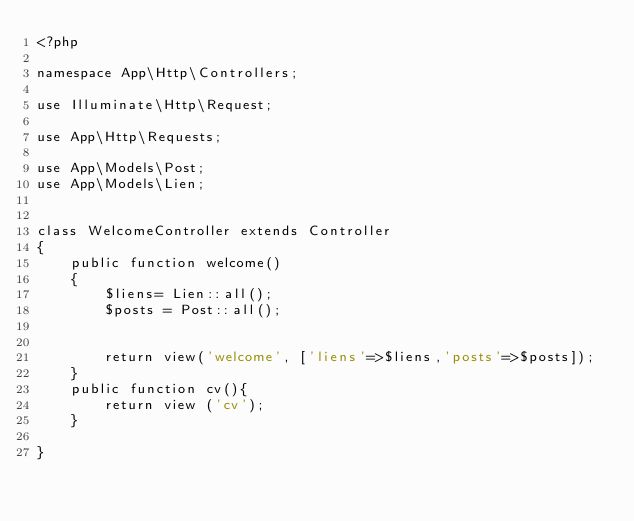Convert code to text. <code><loc_0><loc_0><loc_500><loc_500><_PHP_><?php

namespace App\Http\Controllers;

use Illuminate\Http\Request;

use App\Http\Requests;

use App\Models\Post;
use App\Models\Lien;


class WelcomeController extends Controller
{
    public function welcome()
    {
        $liens= Lien::all();
        $posts = Post::all();


        return view('welcome', ['liens'=>$liens,'posts'=>$posts]);
    }
    public function cv(){
        return view ('cv');
    }
    
}
</code> 